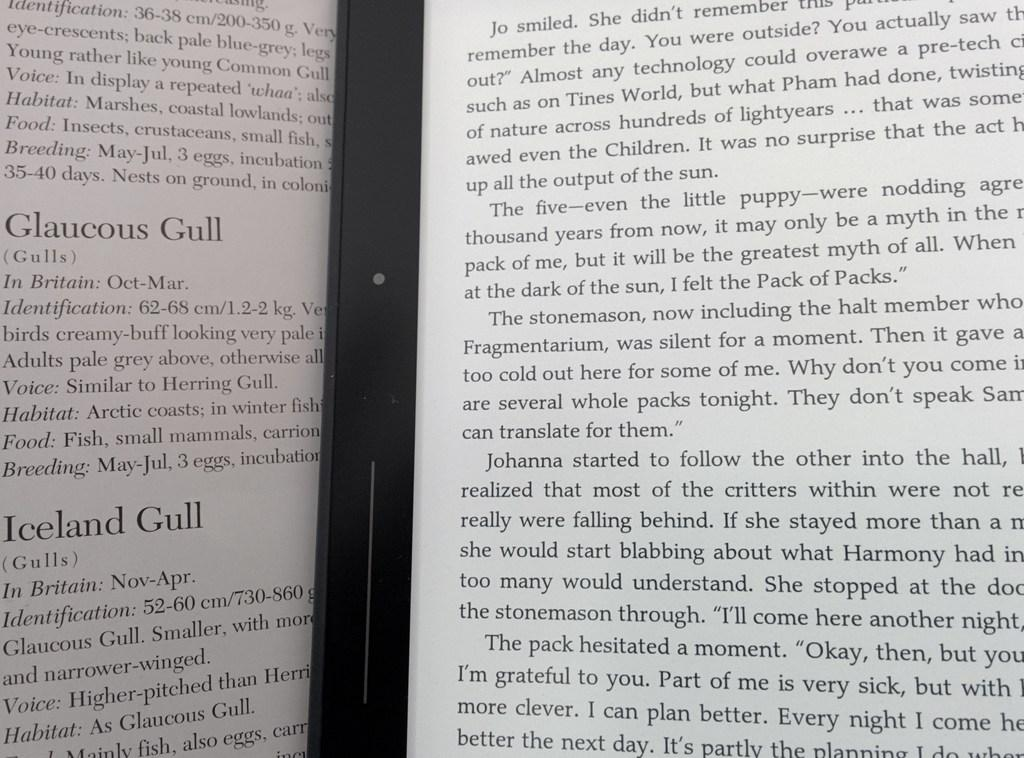<image>
Relay a brief, clear account of the picture shown. A book with a story under the title of Iceland Gull. 